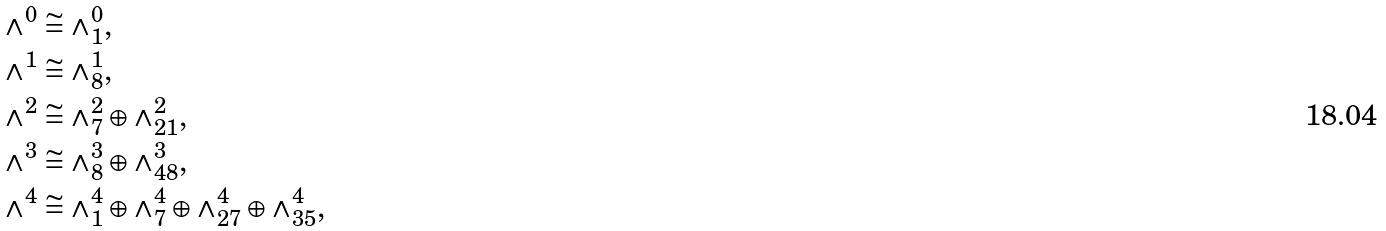<formula> <loc_0><loc_0><loc_500><loc_500>\wedge ^ { 0 } & \cong \wedge ^ { 0 } _ { 1 } , \\ \wedge ^ { 1 } & \cong \wedge ^ { 1 } _ { 8 } , \\ \wedge ^ { 2 } & \cong \wedge ^ { 2 } _ { 7 } \oplus \wedge ^ { 2 } _ { 2 1 } , \\ \wedge ^ { 3 } & \cong \wedge ^ { 3 } _ { 8 } \oplus \wedge ^ { 3 } _ { 4 8 } , \\ \wedge ^ { 4 } & \cong \wedge ^ { 4 } _ { 1 } \oplus \wedge ^ { 4 } _ { 7 } \oplus \wedge ^ { 4 } _ { 2 7 } \oplus \wedge ^ { 4 } _ { 3 5 } ,</formula> 